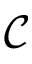<formula> <loc_0><loc_0><loc_500><loc_500>\mathcal { C }</formula> 